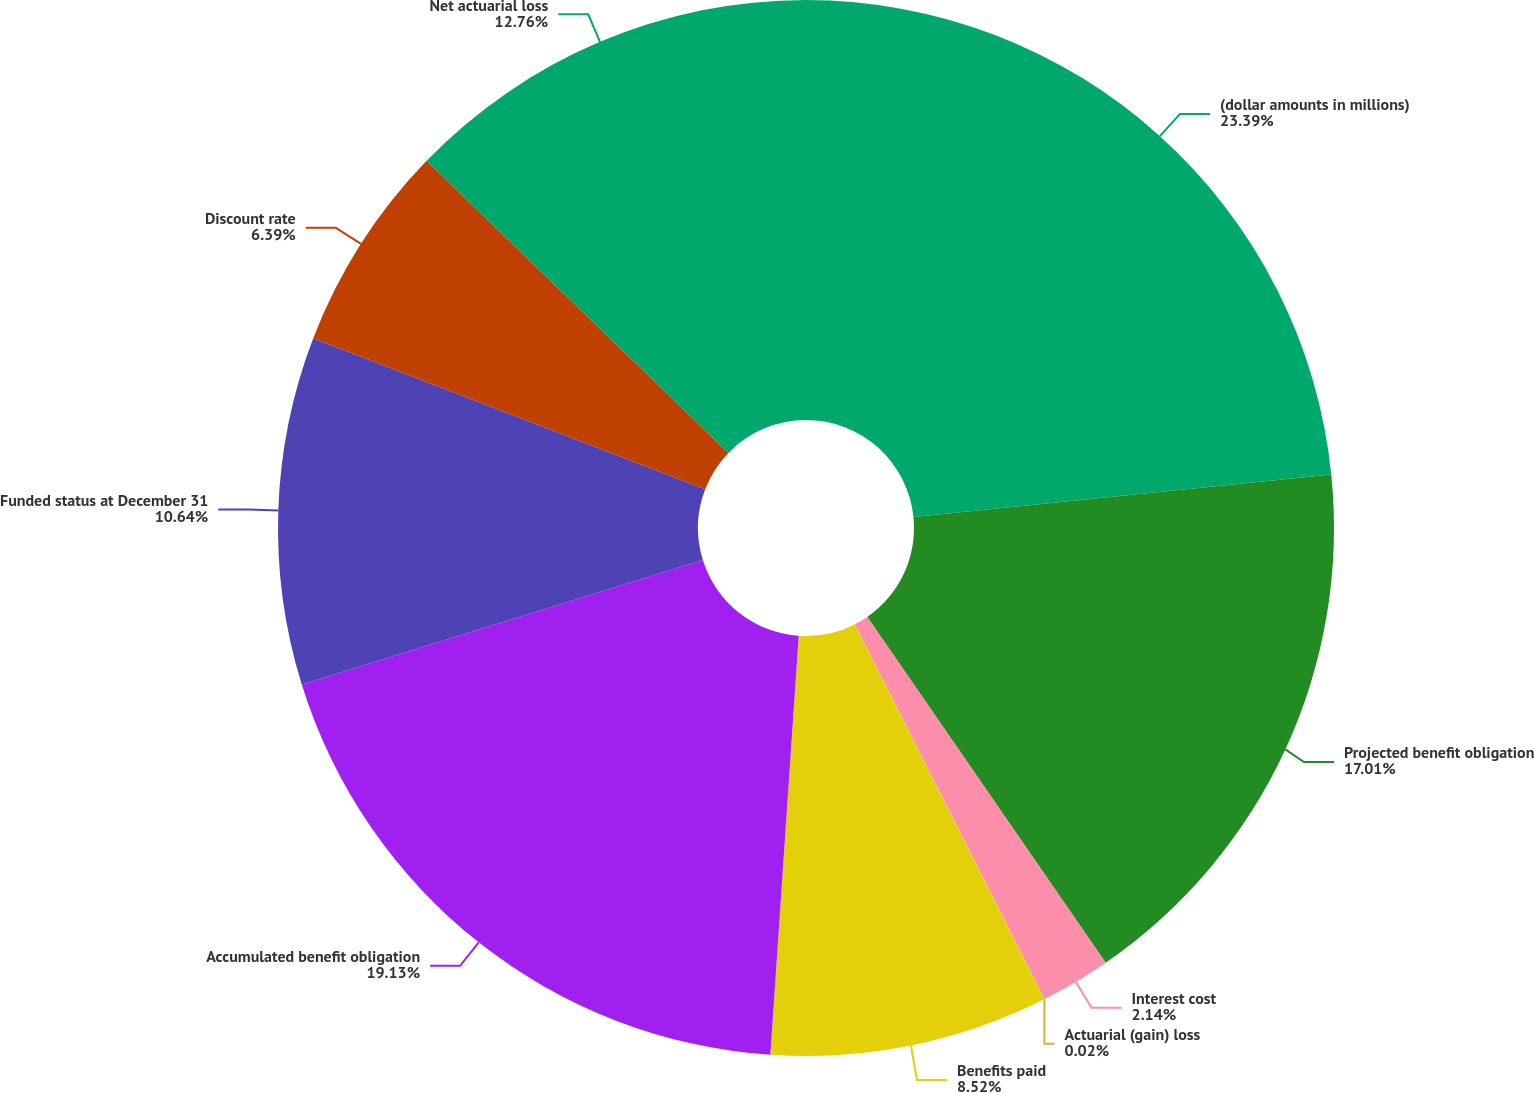<chart> <loc_0><loc_0><loc_500><loc_500><pie_chart><fcel>(dollar amounts in millions)<fcel>Projected benefit obligation<fcel>Interest cost<fcel>Actuarial (gain) loss<fcel>Benefits paid<fcel>Accumulated benefit obligation<fcel>Funded status at December 31<fcel>Discount rate<fcel>Net actuarial loss<nl><fcel>23.38%<fcel>17.01%<fcel>2.14%<fcel>0.02%<fcel>8.52%<fcel>19.13%<fcel>10.64%<fcel>6.39%<fcel>12.76%<nl></chart> 